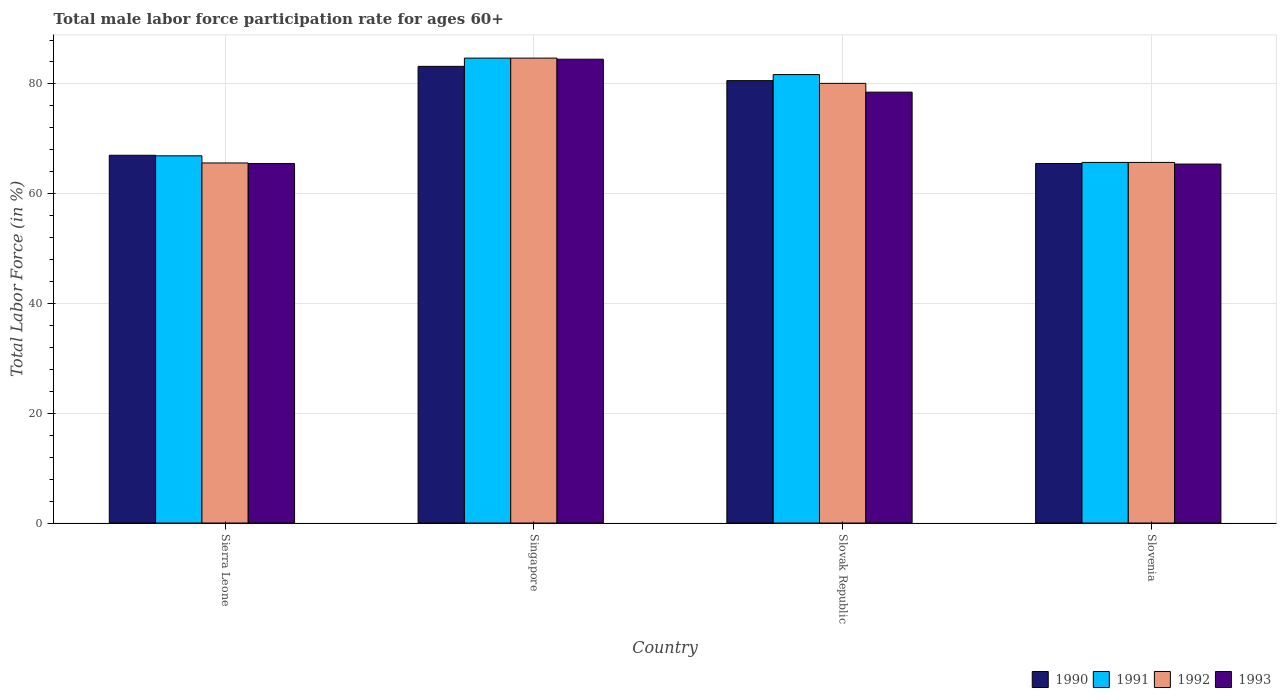How many different coloured bars are there?
Your answer should be compact. 4. Are the number of bars per tick equal to the number of legend labels?
Offer a very short reply. Yes. How many bars are there on the 2nd tick from the left?
Make the answer very short. 4. What is the label of the 3rd group of bars from the left?
Offer a very short reply. Slovak Republic. In how many cases, is the number of bars for a given country not equal to the number of legend labels?
Your response must be concise. 0. What is the male labor force participation rate in 1990 in Slovak Republic?
Ensure brevity in your answer.  80.6. Across all countries, what is the maximum male labor force participation rate in 1991?
Provide a succinct answer. 84.7. Across all countries, what is the minimum male labor force participation rate in 1991?
Ensure brevity in your answer.  65.7. In which country was the male labor force participation rate in 1991 maximum?
Give a very brief answer. Singapore. In which country was the male labor force participation rate in 1993 minimum?
Make the answer very short. Slovenia. What is the total male labor force participation rate in 1991 in the graph?
Your answer should be compact. 299. What is the difference between the male labor force participation rate in 1990 in Sierra Leone and that in Slovak Republic?
Keep it short and to the point. -13.6. What is the difference between the male labor force participation rate in 1993 in Slovak Republic and the male labor force participation rate in 1991 in Singapore?
Make the answer very short. -6.2. What is the average male labor force participation rate in 1991 per country?
Your answer should be compact. 74.75. What is the difference between the male labor force participation rate of/in 1990 and male labor force participation rate of/in 1991 in Singapore?
Provide a succinct answer. -1.5. What is the ratio of the male labor force participation rate in 1991 in Singapore to that in Slovenia?
Your answer should be very brief. 1.29. Is the male labor force participation rate in 1990 in Sierra Leone less than that in Singapore?
Offer a terse response. Yes. Is the difference between the male labor force participation rate in 1990 in Singapore and Slovak Republic greater than the difference between the male labor force participation rate in 1991 in Singapore and Slovak Republic?
Ensure brevity in your answer.  No. What is the difference between the highest and the second highest male labor force participation rate in 1991?
Your response must be concise. 14.8. What is the difference between the highest and the lowest male labor force participation rate in 1990?
Make the answer very short. 17.7. In how many countries, is the male labor force participation rate in 1992 greater than the average male labor force participation rate in 1992 taken over all countries?
Your answer should be compact. 2. Is it the case that in every country, the sum of the male labor force participation rate in 1993 and male labor force participation rate in 1991 is greater than the sum of male labor force participation rate in 1990 and male labor force participation rate in 1992?
Give a very brief answer. No. What does the 1st bar from the left in Slovenia represents?
Your answer should be very brief. 1990. Is it the case that in every country, the sum of the male labor force participation rate in 1990 and male labor force participation rate in 1992 is greater than the male labor force participation rate in 1993?
Offer a very short reply. Yes. How many bars are there?
Your answer should be compact. 16. What is the difference between two consecutive major ticks on the Y-axis?
Give a very brief answer. 20. How many legend labels are there?
Give a very brief answer. 4. What is the title of the graph?
Give a very brief answer. Total male labor force participation rate for ages 60+. What is the Total Labor Force (in %) in 1990 in Sierra Leone?
Provide a short and direct response. 67. What is the Total Labor Force (in %) in 1991 in Sierra Leone?
Ensure brevity in your answer.  66.9. What is the Total Labor Force (in %) of 1992 in Sierra Leone?
Provide a short and direct response. 65.6. What is the Total Labor Force (in %) in 1993 in Sierra Leone?
Ensure brevity in your answer.  65.5. What is the Total Labor Force (in %) in 1990 in Singapore?
Your answer should be very brief. 83.2. What is the Total Labor Force (in %) in 1991 in Singapore?
Provide a succinct answer. 84.7. What is the Total Labor Force (in %) of 1992 in Singapore?
Keep it short and to the point. 84.7. What is the Total Labor Force (in %) in 1993 in Singapore?
Make the answer very short. 84.5. What is the Total Labor Force (in %) of 1990 in Slovak Republic?
Ensure brevity in your answer.  80.6. What is the Total Labor Force (in %) of 1991 in Slovak Republic?
Your answer should be very brief. 81.7. What is the Total Labor Force (in %) of 1992 in Slovak Republic?
Your answer should be very brief. 80.1. What is the Total Labor Force (in %) of 1993 in Slovak Republic?
Make the answer very short. 78.5. What is the Total Labor Force (in %) of 1990 in Slovenia?
Your answer should be very brief. 65.5. What is the Total Labor Force (in %) of 1991 in Slovenia?
Ensure brevity in your answer.  65.7. What is the Total Labor Force (in %) of 1992 in Slovenia?
Ensure brevity in your answer.  65.7. What is the Total Labor Force (in %) in 1993 in Slovenia?
Ensure brevity in your answer.  65.4. Across all countries, what is the maximum Total Labor Force (in %) in 1990?
Provide a short and direct response. 83.2. Across all countries, what is the maximum Total Labor Force (in %) in 1991?
Give a very brief answer. 84.7. Across all countries, what is the maximum Total Labor Force (in %) of 1992?
Your answer should be very brief. 84.7. Across all countries, what is the maximum Total Labor Force (in %) of 1993?
Offer a terse response. 84.5. Across all countries, what is the minimum Total Labor Force (in %) of 1990?
Keep it short and to the point. 65.5. Across all countries, what is the minimum Total Labor Force (in %) of 1991?
Your response must be concise. 65.7. Across all countries, what is the minimum Total Labor Force (in %) of 1992?
Make the answer very short. 65.6. Across all countries, what is the minimum Total Labor Force (in %) of 1993?
Your answer should be very brief. 65.4. What is the total Total Labor Force (in %) of 1990 in the graph?
Offer a very short reply. 296.3. What is the total Total Labor Force (in %) of 1991 in the graph?
Your response must be concise. 299. What is the total Total Labor Force (in %) of 1992 in the graph?
Make the answer very short. 296.1. What is the total Total Labor Force (in %) of 1993 in the graph?
Ensure brevity in your answer.  293.9. What is the difference between the Total Labor Force (in %) of 1990 in Sierra Leone and that in Singapore?
Your answer should be very brief. -16.2. What is the difference between the Total Labor Force (in %) in 1991 in Sierra Leone and that in Singapore?
Your answer should be compact. -17.8. What is the difference between the Total Labor Force (in %) in 1992 in Sierra Leone and that in Singapore?
Provide a short and direct response. -19.1. What is the difference between the Total Labor Force (in %) of 1990 in Sierra Leone and that in Slovak Republic?
Give a very brief answer. -13.6. What is the difference between the Total Labor Force (in %) of 1991 in Sierra Leone and that in Slovak Republic?
Offer a very short reply. -14.8. What is the difference between the Total Labor Force (in %) of 1992 in Sierra Leone and that in Slovak Republic?
Your response must be concise. -14.5. What is the difference between the Total Labor Force (in %) of 1990 in Sierra Leone and that in Slovenia?
Ensure brevity in your answer.  1.5. What is the difference between the Total Labor Force (in %) in 1991 in Sierra Leone and that in Slovenia?
Offer a terse response. 1.2. What is the difference between the Total Labor Force (in %) of 1992 in Sierra Leone and that in Slovenia?
Provide a succinct answer. -0.1. What is the difference between the Total Labor Force (in %) of 1990 in Singapore and that in Slovak Republic?
Make the answer very short. 2.6. What is the difference between the Total Labor Force (in %) of 1992 in Singapore and that in Slovak Republic?
Ensure brevity in your answer.  4.6. What is the difference between the Total Labor Force (in %) of 1993 in Singapore and that in Slovak Republic?
Your answer should be very brief. 6. What is the difference between the Total Labor Force (in %) in 1990 in Singapore and that in Slovenia?
Keep it short and to the point. 17.7. What is the difference between the Total Labor Force (in %) in 1991 in Singapore and that in Slovenia?
Ensure brevity in your answer.  19. What is the difference between the Total Labor Force (in %) of 1992 in Singapore and that in Slovenia?
Give a very brief answer. 19. What is the difference between the Total Labor Force (in %) of 1991 in Slovak Republic and that in Slovenia?
Give a very brief answer. 16. What is the difference between the Total Labor Force (in %) of 1990 in Sierra Leone and the Total Labor Force (in %) of 1991 in Singapore?
Keep it short and to the point. -17.7. What is the difference between the Total Labor Force (in %) in 1990 in Sierra Leone and the Total Labor Force (in %) in 1992 in Singapore?
Your response must be concise. -17.7. What is the difference between the Total Labor Force (in %) of 1990 in Sierra Leone and the Total Labor Force (in %) of 1993 in Singapore?
Your answer should be compact. -17.5. What is the difference between the Total Labor Force (in %) in 1991 in Sierra Leone and the Total Labor Force (in %) in 1992 in Singapore?
Your answer should be very brief. -17.8. What is the difference between the Total Labor Force (in %) in 1991 in Sierra Leone and the Total Labor Force (in %) in 1993 in Singapore?
Give a very brief answer. -17.6. What is the difference between the Total Labor Force (in %) in 1992 in Sierra Leone and the Total Labor Force (in %) in 1993 in Singapore?
Make the answer very short. -18.9. What is the difference between the Total Labor Force (in %) in 1990 in Sierra Leone and the Total Labor Force (in %) in 1991 in Slovak Republic?
Your response must be concise. -14.7. What is the difference between the Total Labor Force (in %) in 1990 in Sierra Leone and the Total Labor Force (in %) in 1993 in Slovak Republic?
Your answer should be very brief. -11.5. What is the difference between the Total Labor Force (in %) of 1991 in Sierra Leone and the Total Labor Force (in %) of 1992 in Slovak Republic?
Give a very brief answer. -13.2. What is the difference between the Total Labor Force (in %) in 1991 in Sierra Leone and the Total Labor Force (in %) in 1993 in Slovak Republic?
Make the answer very short. -11.6. What is the difference between the Total Labor Force (in %) of 1990 in Sierra Leone and the Total Labor Force (in %) of 1992 in Slovenia?
Provide a short and direct response. 1.3. What is the difference between the Total Labor Force (in %) in 1991 in Sierra Leone and the Total Labor Force (in %) in 1993 in Slovenia?
Your answer should be very brief. 1.5. What is the difference between the Total Labor Force (in %) of 1990 in Singapore and the Total Labor Force (in %) of 1991 in Slovak Republic?
Make the answer very short. 1.5. What is the difference between the Total Labor Force (in %) of 1991 in Singapore and the Total Labor Force (in %) of 1993 in Slovak Republic?
Make the answer very short. 6.2. What is the difference between the Total Labor Force (in %) in 1990 in Singapore and the Total Labor Force (in %) in 1991 in Slovenia?
Keep it short and to the point. 17.5. What is the difference between the Total Labor Force (in %) in 1990 in Singapore and the Total Labor Force (in %) in 1992 in Slovenia?
Give a very brief answer. 17.5. What is the difference between the Total Labor Force (in %) of 1990 in Singapore and the Total Labor Force (in %) of 1993 in Slovenia?
Provide a short and direct response. 17.8. What is the difference between the Total Labor Force (in %) in 1991 in Singapore and the Total Labor Force (in %) in 1992 in Slovenia?
Provide a succinct answer. 19. What is the difference between the Total Labor Force (in %) in 1991 in Singapore and the Total Labor Force (in %) in 1993 in Slovenia?
Keep it short and to the point. 19.3. What is the difference between the Total Labor Force (in %) of 1992 in Singapore and the Total Labor Force (in %) of 1993 in Slovenia?
Ensure brevity in your answer.  19.3. What is the difference between the Total Labor Force (in %) in 1990 in Slovak Republic and the Total Labor Force (in %) in 1992 in Slovenia?
Your response must be concise. 14.9. What is the difference between the Total Labor Force (in %) of 1990 in Slovak Republic and the Total Labor Force (in %) of 1993 in Slovenia?
Make the answer very short. 15.2. What is the difference between the Total Labor Force (in %) in 1992 in Slovak Republic and the Total Labor Force (in %) in 1993 in Slovenia?
Your answer should be very brief. 14.7. What is the average Total Labor Force (in %) of 1990 per country?
Your answer should be compact. 74.08. What is the average Total Labor Force (in %) in 1991 per country?
Provide a succinct answer. 74.75. What is the average Total Labor Force (in %) in 1992 per country?
Your response must be concise. 74.03. What is the average Total Labor Force (in %) in 1993 per country?
Your answer should be very brief. 73.47. What is the difference between the Total Labor Force (in %) in 1991 and Total Labor Force (in %) in 1992 in Sierra Leone?
Keep it short and to the point. 1.3. What is the difference between the Total Labor Force (in %) of 1991 and Total Labor Force (in %) of 1993 in Sierra Leone?
Your answer should be very brief. 1.4. What is the difference between the Total Labor Force (in %) in 1992 and Total Labor Force (in %) in 1993 in Sierra Leone?
Your response must be concise. 0.1. What is the difference between the Total Labor Force (in %) in 1990 and Total Labor Force (in %) in 1992 in Singapore?
Give a very brief answer. -1.5. What is the difference between the Total Labor Force (in %) of 1990 and Total Labor Force (in %) of 1991 in Slovak Republic?
Provide a short and direct response. -1.1. What is the difference between the Total Labor Force (in %) in 1991 and Total Labor Force (in %) in 1992 in Slovak Republic?
Give a very brief answer. 1.6. What is the ratio of the Total Labor Force (in %) in 1990 in Sierra Leone to that in Singapore?
Your answer should be very brief. 0.81. What is the ratio of the Total Labor Force (in %) in 1991 in Sierra Leone to that in Singapore?
Your response must be concise. 0.79. What is the ratio of the Total Labor Force (in %) of 1992 in Sierra Leone to that in Singapore?
Offer a very short reply. 0.77. What is the ratio of the Total Labor Force (in %) of 1993 in Sierra Leone to that in Singapore?
Offer a terse response. 0.78. What is the ratio of the Total Labor Force (in %) in 1990 in Sierra Leone to that in Slovak Republic?
Provide a short and direct response. 0.83. What is the ratio of the Total Labor Force (in %) in 1991 in Sierra Leone to that in Slovak Republic?
Your answer should be compact. 0.82. What is the ratio of the Total Labor Force (in %) of 1992 in Sierra Leone to that in Slovak Republic?
Provide a short and direct response. 0.82. What is the ratio of the Total Labor Force (in %) in 1993 in Sierra Leone to that in Slovak Republic?
Give a very brief answer. 0.83. What is the ratio of the Total Labor Force (in %) in 1990 in Sierra Leone to that in Slovenia?
Keep it short and to the point. 1.02. What is the ratio of the Total Labor Force (in %) in 1991 in Sierra Leone to that in Slovenia?
Offer a terse response. 1.02. What is the ratio of the Total Labor Force (in %) of 1990 in Singapore to that in Slovak Republic?
Offer a terse response. 1.03. What is the ratio of the Total Labor Force (in %) of 1991 in Singapore to that in Slovak Republic?
Make the answer very short. 1.04. What is the ratio of the Total Labor Force (in %) in 1992 in Singapore to that in Slovak Republic?
Offer a very short reply. 1.06. What is the ratio of the Total Labor Force (in %) in 1993 in Singapore to that in Slovak Republic?
Offer a very short reply. 1.08. What is the ratio of the Total Labor Force (in %) in 1990 in Singapore to that in Slovenia?
Your answer should be compact. 1.27. What is the ratio of the Total Labor Force (in %) in 1991 in Singapore to that in Slovenia?
Give a very brief answer. 1.29. What is the ratio of the Total Labor Force (in %) in 1992 in Singapore to that in Slovenia?
Your answer should be compact. 1.29. What is the ratio of the Total Labor Force (in %) of 1993 in Singapore to that in Slovenia?
Give a very brief answer. 1.29. What is the ratio of the Total Labor Force (in %) of 1990 in Slovak Republic to that in Slovenia?
Ensure brevity in your answer.  1.23. What is the ratio of the Total Labor Force (in %) in 1991 in Slovak Republic to that in Slovenia?
Offer a very short reply. 1.24. What is the ratio of the Total Labor Force (in %) in 1992 in Slovak Republic to that in Slovenia?
Your response must be concise. 1.22. What is the ratio of the Total Labor Force (in %) in 1993 in Slovak Republic to that in Slovenia?
Provide a succinct answer. 1.2. What is the difference between the highest and the second highest Total Labor Force (in %) in 1990?
Offer a terse response. 2.6. What is the difference between the highest and the second highest Total Labor Force (in %) in 1991?
Provide a succinct answer. 3. What is the difference between the highest and the lowest Total Labor Force (in %) of 1991?
Provide a short and direct response. 19. What is the difference between the highest and the lowest Total Labor Force (in %) in 1992?
Offer a very short reply. 19.1. 